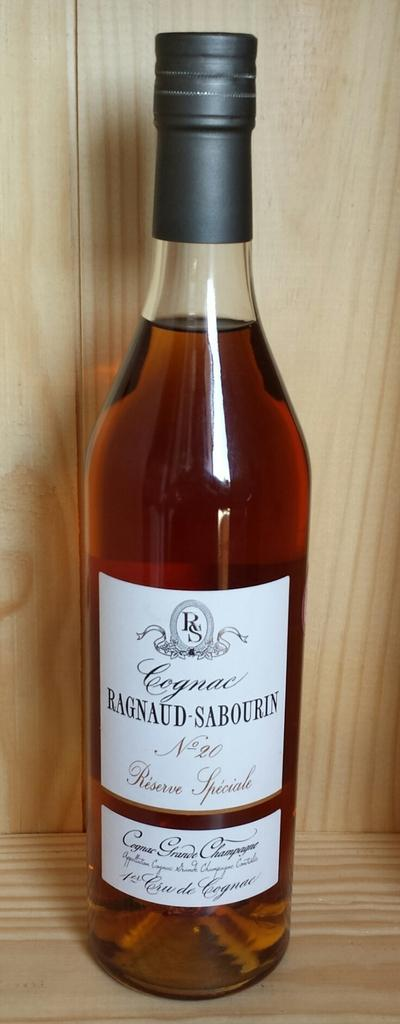Provide a one-sentence caption for the provided image. A bottle of Ragnaud-Sabourin cognac sits in a pale wood cabinet. 